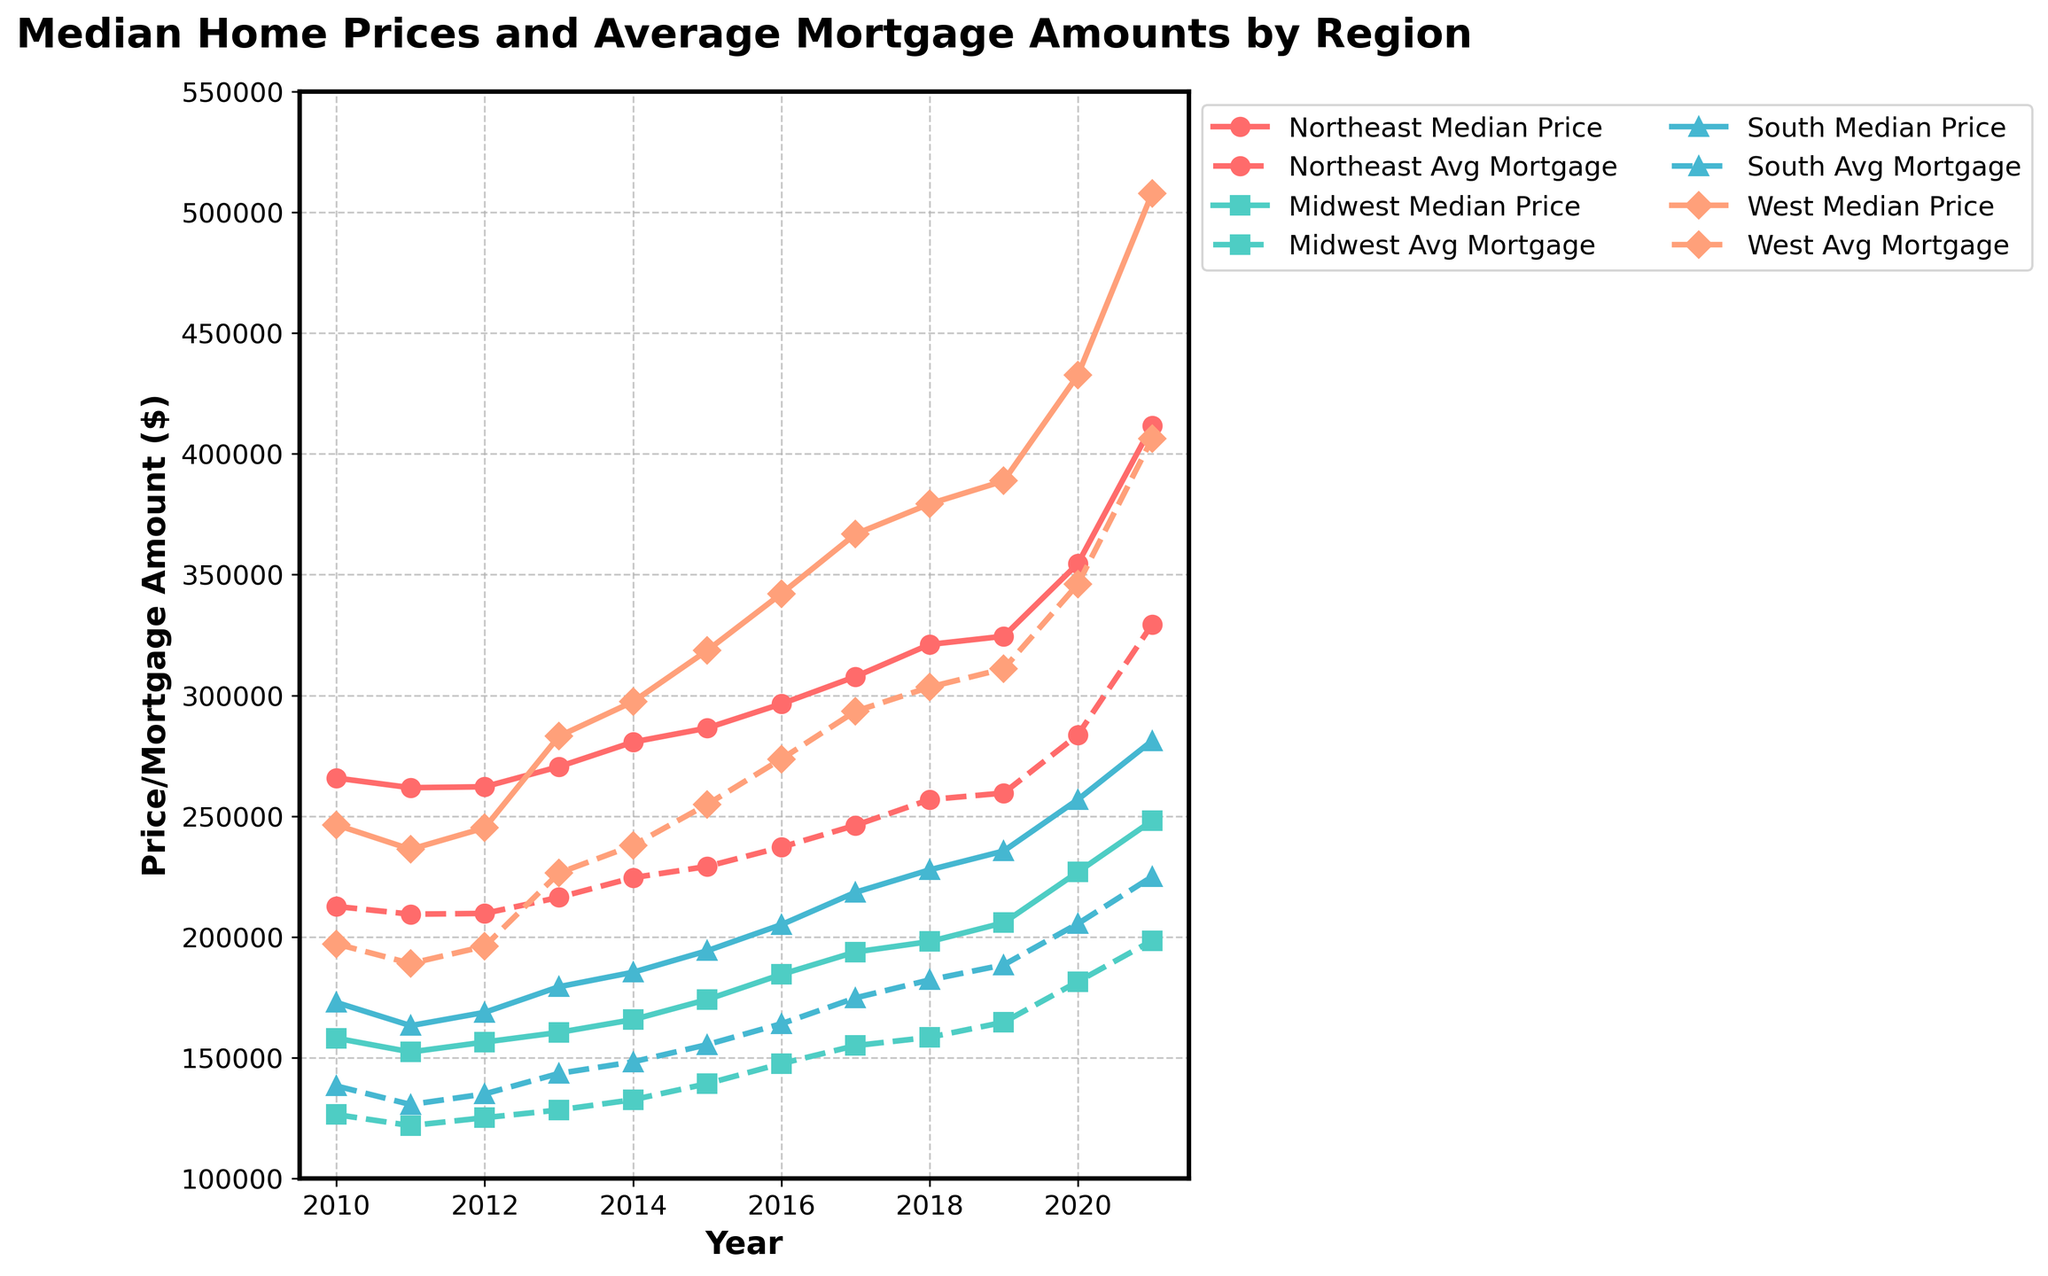what trend can you observe in the median home prices in the West region from 2010 to 2021? Step-by-Step Explanation: Look at the solid line denoted by the specific color/marker for the West region. Notice how it starts around $246,400 in 2010 and reaches approximately $507,800 in 2021, consistently moving upwards. This indicates an increasing trend in the median home prices in the West region over time.
Answer: Increasing How does the average mortgage amount in the Northeast region in 2021 compare to that in the Midwest region in 2017? Step-by-Step Explanation: Look at the dashed line for the Northeast region in 2021; it is approximately $329,360. Then look at the dashed line for the Midwest region in 2017; it is around $155,040. Comparing these values, $329,360 (Northeast 2021) is greater than $155,040 (Midwest 2017).
Answer: Northeast 2021 is greater Did the South region ever exceed the West region in median home prices from 2010 to 2021? Step-by-Step Explanation: Observe the solid lines for both the South and West regions throughout the years from 2010 to 2021. Notice that the solid line for the South never surpasses the solid line for the West during this period. Thus, the South region didn't exceed the West region in median home prices at any time.
Answer: No Which year showed the maximum gap between median home prices and average mortgage amounts in the Midwest region? Step-by-Step Explanation: For each year, calculate the difference between the Midwest median home prices (solid line) and the Midwest average mortgage (dashed line). The differences are largest when the median home prices are around $226,900 and the average mortgage amounts are around $181,520 in 2020.
Answer: 2020 Compare the trends of median home prices between the Northeast and Midwest regions from 2010 to 2015. Step-by-Step Explanation: Look at the solid lines for the Northeast and Midwest regions. From 2010 to 2015, Northeast starts at $265,800 and moves to $286,500. Midwest starts at $158,100 and goes to $174,100. Both show an upward trend, but Northeast has a higher increase compared to the Midwest within these years.
Answer: Both upward; Northeast higher What are the median home price differences between the South and Northeast regions in 2012 and 2021? Step-by-Step Explanation: In 2012, the median home price in the South is around $168,800, and in the Northeast it is around $262,200; the difference is $262,200 - $168,800 = $93,400. In 2021, the median home price in the South is about $281,200, and in the Northeast it is about $411,700; the difference is $411,700 - $281,200 = $130,500.
Answer: $93,400 and $130,500 Which region had the highest average mortgage amount in 2020, and what was that amount? Step-by-Step Explanation: Observe the dashed lines for all regions in 2020. The West region line is highest, with an average mortgage amount around $346,080.
Answer: West; $346,080 Identify the region with the smallest growth in average mortgage amounts from 2010 to 2021. Step-by-Step Explanation: Calculate the difference between 2021 and 2010 for each region's average mortgage amount (dashed lines). Northeast: $329,360 - $212,640 = $116,720, Midwest: $198,480 - $126,480 = $72,000, South: $224,960 - $138,320 = $86,640, West: $406,240 - $197,120 = $209,120. The smallest growth is observed in the Midwest with $72,000.
Answer: Midwest Which year did the South region’s median home prices first exceed $200,000? Step-by-Step Explanation: Observe the solid line for the South region. It first exceeds $200,000 around 2016 when the median home price is about $205,100.
Answer: 2016 